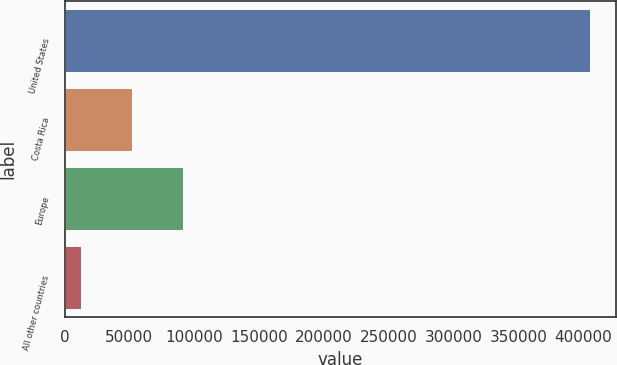Convert chart to OTSL. <chart><loc_0><loc_0><loc_500><loc_500><bar_chart><fcel>United States<fcel>Costa Rica<fcel>Europe<fcel>All other countries<nl><fcel>405141<fcel>51744.3<fcel>91010.6<fcel>12478<nl></chart> 